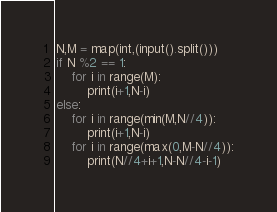Convert code to text. <code><loc_0><loc_0><loc_500><loc_500><_Python_>N,M = map(int,(input().split()))
if N %2 == 1:
    for i in range(M):
        print(i+1,N-i)
else:
    for i in range(min(M,N//4)):
        print(i+1,N-i)
    for i in range(max(0,M-N//4)):
        print(N//4+i+1,N-N//4-i-1)</code> 